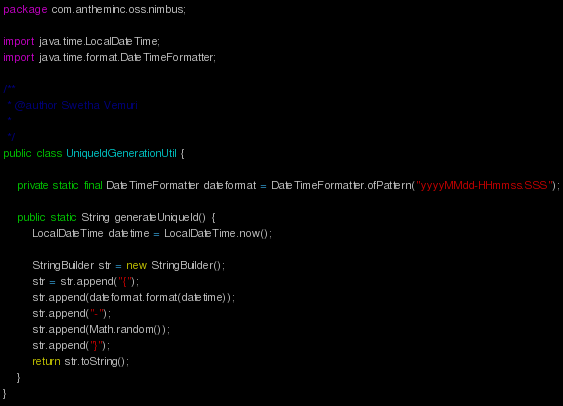Convert code to text. <code><loc_0><loc_0><loc_500><loc_500><_Java_>package com.antheminc.oss.nimbus;

import java.time.LocalDateTime;
import java.time.format.DateTimeFormatter;

/**
 * @author Swetha Vemuri
 *
 */
public class UniqueIdGenerationUtil {

	private static final DateTimeFormatter dateformat = DateTimeFormatter.ofPattern("yyyyMMdd-HHmmss.SSS");
	
	public static String generateUniqueId() {
		LocalDateTime datetime = LocalDateTime.now();
		
		StringBuilder str = new StringBuilder();
		str = str.append("{");
		str.append(dateformat.format(datetime));
		str.append("-");
		str.append(Math.random());
		str.append("}");
		return str.toString();		
	}
}
</code> 